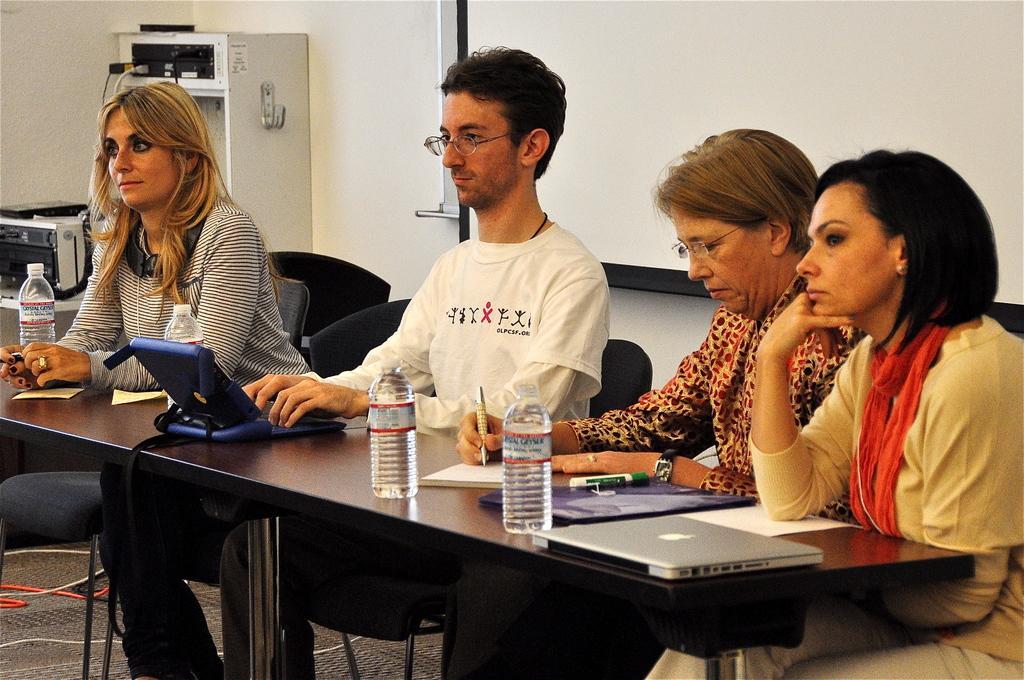How would you summarize this image in a sentence or two? In this picture we can see four people one man and three women sitting in front of a table, there is a laptop on the table and we can see two water bottles here and the man sitting is typing in his keyboard, on the background we can see projector screen, on the left side of the image we can see a machine, the woman second from the right side is writing something in paper. 